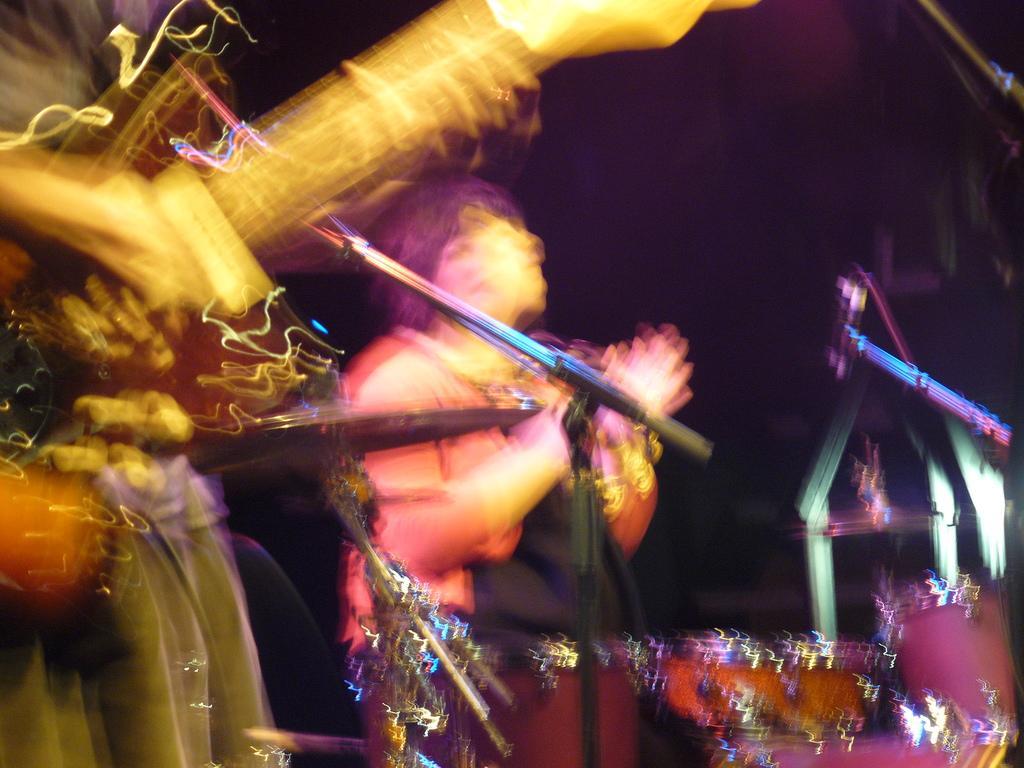Please provide a concise description of this image. This is a blur image. Here I can see two persons. One person is playing the guitar. In the middle of the image there is a mike stand. The background is in black color. 